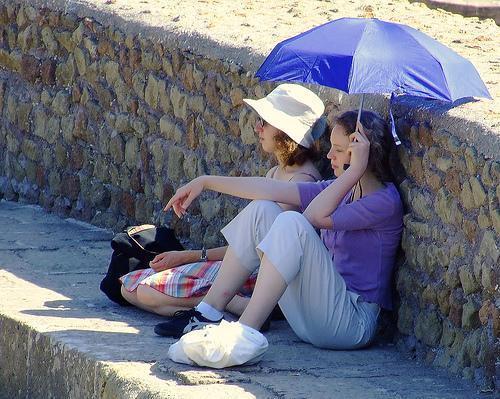How many people are shown?
Give a very brief answer. 2. 